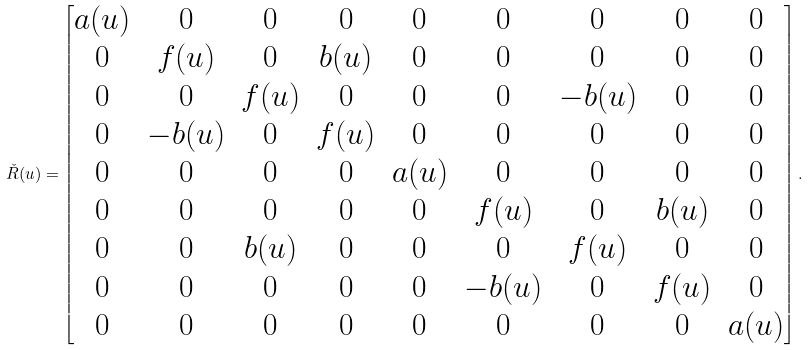<formula> <loc_0><loc_0><loc_500><loc_500>\check { R } ( u ) = \begin{bmatrix} a ( u ) & 0 & 0 & 0 & 0 & 0 & 0 & 0 & 0 \\ 0 & f ( u ) & 0 & b ( u ) & 0 & 0 & 0 & 0 & 0 \\ 0 & 0 & f ( u ) & 0 & 0 & 0 & - b ( u ) & 0 & 0 \\ 0 & - b ( u ) & 0 & f ( u ) & 0 & 0 & 0 & 0 & 0 \\ 0 & 0 & 0 & 0 & a ( u ) & 0 & 0 & 0 & 0 \\ 0 & 0 & 0 & 0 & 0 & f ( u ) & 0 & b ( u ) & 0 \\ 0 & 0 & b ( u ) & 0 & 0 & 0 & f ( u ) & 0 & 0 \\ 0 & 0 & 0 & 0 & 0 & - b ( u ) & 0 & f ( u ) & 0 \\ 0 & 0 & 0 & 0 & 0 & 0 & 0 & 0 & a ( u ) \end{bmatrix} .</formula> 